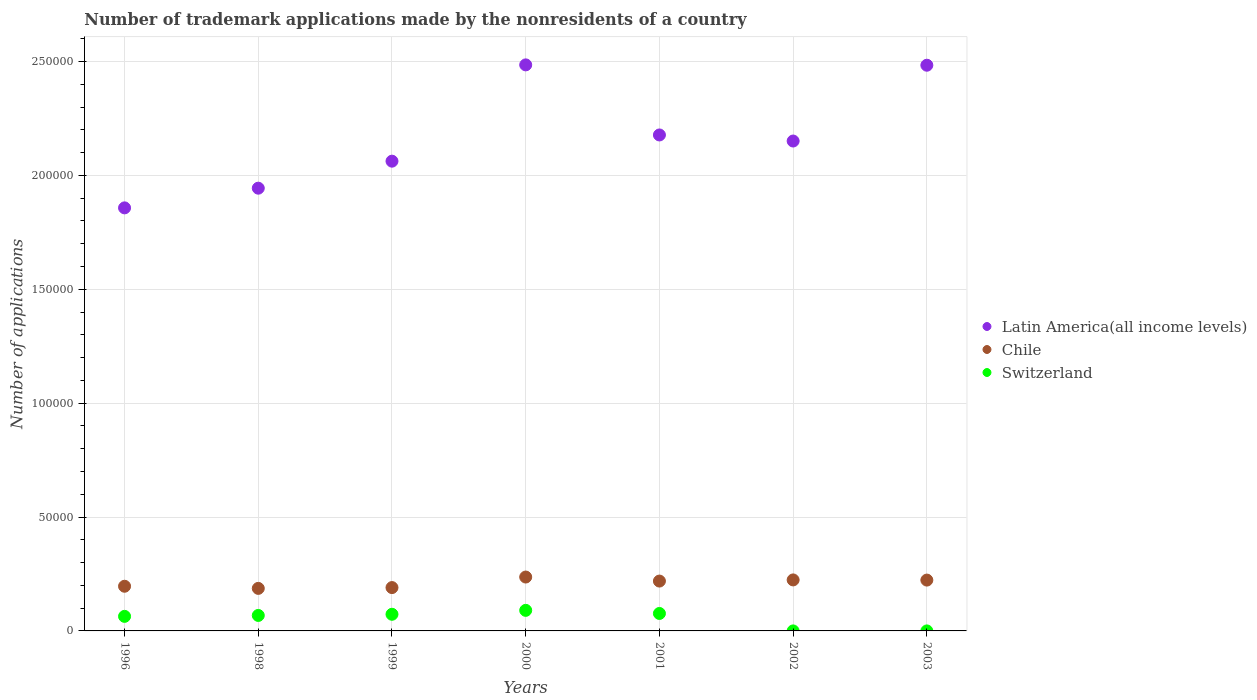Is the number of dotlines equal to the number of legend labels?
Ensure brevity in your answer.  Yes. What is the number of trademark applications made by the nonresidents in Chile in 2001?
Ensure brevity in your answer.  2.19e+04. Across all years, what is the maximum number of trademark applications made by the nonresidents in Latin America(all income levels)?
Your answer should be very brief. 2.49e+05. Across all years, what is the minimum number of trademark applications made by the nonresidents in Chile?
Give a very brief answer. 1.87e+04. In which year was the number of trademark applications made by the nonresidents in Latin America(all income levels) minimum?
Provide a succinct answer. 1996. What is the total number of trademark applications made by the nonresidents in Switzerland in the graph?
Give a very brief answer. 3.72e+04. What is the difference between the number of trademark applications made by the nonresidents in Switzerland in 1996 and that in 2000?
Make the answer very short. -2640. What is the difference between the number of trademark applications made by the nonresidents in Switzerland in 1998 and the number of trademark applications made by the nonresidents in Chile in 2001?
Your response must be concise. -1.51e+04. What is the average number of trademark applications made by the nonresidents in Chile per year?
Provide a succinct answer. 2.11e+04. In the year 2002, what is the difference between the number of trademark applications made by the nonresidents in Chile and number of trademark applications made by the nonresidents in Latin America(all income levels)?
Provide a short and direct response. -1.93e+05. In how many years, is the number of trademark applications made by the nonresidents in Latin America(all income levels) greater than 150000?
Offer a terse response. 7. What is the ratio of the number of trademark applications made by the nonresidents in Chile in 2000 to that in 2003?
Offer a terse response. 1.06. What is the difference between the highest and the second highest number of trademark applications made by the nonresidents in Switzerland?
Ensure brevity in your answer.  1365. What is the difference between the highest and the lowest number of trademark applications made by the nonresidents in Latin America(all income levels)?
Your answer should be very brief. 6.28e+04. Is it the case that in every year, the sum of the number of trademark applications made by the nonresidents in Switzerland and number of trademark applications made by the nonresidents in Latin America(all income levels)  is greater than the number of trademark applications made by the nonresidents in Chile?
Give a very brief answer. Yes. Is the number of trademark applications made by the nonresidents in Switzerland strictly less than the number of trademark applications made by the nonresidents in Latin America(all income levels) over the years?
Your response must be concise. Yes. How many dotlines are there?
Keep it short and to the point. 3. How many years are there in the graph?
Ensure brevity in your answer.  7. What is the difference between two consecutive major ticks on the Y-axis?
Your answer should be very brief. 5.00e+04. Are the values on the major ticks of Y-axis written in scientific E-notation?
Your answer should be compact. No. Does the graph contain grids?
Your answer should be compact. Yes. Where does the legend appear in the graph?
Make the answer very short. Center right. How many legend labels are there?
Provide a succinct answer. 3. How are the legend labels stacked?
Your answer should be very brief. Vertical. What is the title of the graph?
Offer a very short reply. Number of trademark applications made by the nonresidents of a country. Does "Georgia" appear as one of the legend labels in the graph?
Give a very brief answer. No. What is the label or title of the X-axis?
Ensure brevity in your answer.  Years. What is the label or title of the Y-axis?
Make the answer very short. Number of applications. What is the Number of applications in Latin America(all income levels) in 1996?
Give a very brief answer. 1.86e+05. What is the Number of applications of Chile in 1996?
Ensure brevity in your answer.  1.96e+04. What is the Number of applications in Switzerland in 1996?
Keep it short and to the point. 6390. What is the Number of applications in Latin America(all income levels) in 1998?
Ensure brevity in your answer.  1.94e+05. What is the Number of applications in Chile in 1998?
Your answer should be compact. 1.87e+04. What is the Number of applications in Switzerland in 1998?
Your response must be concise. 6796. What is the Number of applications in Latin America(all income levels) in 1999?
Offer a terse response. 2.06e+05. What is the Number of applications of Chile in 1999?
Offer a terse response. 1.90e+04. What is the Number of applications of Switzerland in 1999?
Ensure brevity in your answer.  7307. What is the Number of applications in Latin America(all income levels) in 2000?
Ensure brevity in your answer.  2.49e+05. What is the Number of applications in Chile in 2000?
Ensure brevity in your answer.  2.37e+04. What is the Number of applications in Switzerland in 2000?
Your answer should be very brief. 9030. What is the Number of applications in Latin America(all income levels) in 2001?
Offer a very short reply. 2.18e+05. What is the Number of applications in Chile in 2001?
Provide a succinct answer. 2.19e+04. What is the Number of applications in Switzerland in 2001?
Offer a terse response. 7665. What is the Number of applications in Latin America(all income levels) in 2002?
Provide a short and direct response. 2.15e+05. What is the Number of applications in Chile in 2002?
Your answer should be compact. 2.24e+04. What is the Number of applications in Latin America(all income levels) in 2003?
Provide a short and direct response. 2.48e+05. What is the Number of applications in Chile in 2003?
Ensure brevity in your answer.  2.23e+04. What is the Number of applications in Switzerland in 2003?
Keep it short and to the point. 1. Across all years, what is the maximum Number of applications of Latin America(all income levels)?
Give a very brief answer. 2.49e+05. Across all years, what is the maximum Number of applications in Chile?
Give a very brief answer. 2.37e+04. Across all years, what is the maximum Number of applications in Switzerland?
Provide a succinct answer. 9030. Across all years, what is the minimum Number of applications of Latin America(all income levels)?
Provide a short and direct response. 1.86e+05. Across all years, what is the minimum Number of applications in Chile?
Ensure brevity in your answer.  1.87e+04. Across all years, what is the minimum Number of applications in Switzerland?
Ensure brevity in your answer.  1. What is the total Number of applications of Latin America(all income levels) in the graph?
Provide a succinct answer. 1.52e+06. What is the total Number of applications of Chile in the graph?
Offer a very short reply. 1.48e+05. What is the total Number of applications in Switzerland in the graph?
Keep it short and to the point. 3.72e+04. What is the difference between the Number of applications of Latin America(all income levels) in 1996 and that in 1998?
Make the answer very short. -8641. What is the difference between the Number of applications in Chile in 1996 and that in 1998?
Offer a terse response. 937. What is the difference between the Number of applications of Switzerland in 1996 and that in 1998?
Make the answer very short. -406. What is the difference between the Number of applications in Latin America(all income levels) in 1996 and that in 1999?
Offer a terse response. -2.05e+04. What is the difference between the Number of applications in Chile in 1996 and that in 1999?
Provide a succinct answer. 585. What is the difference between the Number of applications of Switzerland in 1996 and that in 1999?
Your response must be concise. -917. What is the difference between the Number of applications of Latin America(all income levels) in 1996 and that in 2000?
Your response must be concise. -6.28e+04. What is the difference between the Number of applications of Chile in 1996 and that in 2000?
Provide a short and direct response. -4044. What is the difference between the Number of applications in Switzerland in 1996 and that in 2000?
Provide a short and direct response. -2640. What is the difference between the Number of applications of Latin America(all income levels) in 1996 and that in 2001?
Keep it short and to the point. -3.20e+04. What is the difference between the Number of applications of Chile in 1996 and that in 2001?
Provide a short and direct response. -2274. What is the difference between the Number of applications in Switzerland in 1996 and that in 2001?
Keep it short and to the point. -1275. What is the difference between the Number of applications of Latin America(all income levels) in 1996 and that in 2002?
Give a very brief answer. -2.93e+04. What is the difference between the Number of applications of Chile in 1996 and that in 2002?
Offer a terse response. -2779. What is the difference between the Number of applications of Switzerland in 1996 and that in 2002?
Keep it short and to the point. 6389. What is the difference between the Number of applications in Latin America(all income levels) in 1996 and that in 2003?
Make the answer very short. -6.26e+04. What is the difference between the Number of applications of Chile in 1996 and that in 2003?
Your response must be concise. -2705. What is the difference between the Number of applications in Switzerland in 1996 and that in 2003?
Your answer should be very brief. 6389. What is the difference between the Number of applications of Latin America(all income levels) in 1998 and that in 1999?
Give a very brief answer. -1.19e+04. What is the difference between the Number of applications of Chile in 1998 and that in 1999?
Offer a very short reply. -352. What is the difference between the Number of applications of Switzerland in 1998 and that in 1999?
Make the answer very short. -511. What is the difference between the Number of applications of Latin America(all income levels) in 1998 and that in 2000?
Offer a terse response. -5.41e+04. What is the difference between the Number of applications of Chile in 1998 and that in 2000?
Ensure brevity in your answer.  -4981. What is the difference between the Number of applications in Switzerland in 1998 and that in 2000?
Make the answer very short. -2234. What is the difference between the Number of applications in Latin America(all income levels) in 1998 and that in 2001?
Offer a terse response. -2.34e+04. What is the difference between the Number of applications in Chile in 1998 and that in 2001?
Give a very brief answer. -3211. What is the difference between the Number of applications of Switzerland in 1998 and that in 2001?
Make the answer very short. -869. What is the difference between the Number of applications in Latin America(all income levels) in 1998 and that in 2002?
Keep it short and to the point. -2.07e+04. What is the difference between the Number of applications in Chile in 1998 and that in 2002?
Keep it short and to the point. -3716. What is the difference between the Number of applications in Switzerland in 1998 and that in 2002?
Keep it short and to the point. 6795. What is the difference between the Number of applications of Latin America(all income levels) in 1998 and that in 2003?
Offer a very short reply. -5.40e+04. What is the difference between the Number of applications in Chile in 1998 and that in 2003?
Your answer should be very brief. -3642. What is the difference between the Number of applications of Switzerland in 1998 and that in 2003?
Give a very brief answer. 6795. What is the difference between the Number of applications of Latin America(all income levels) in 1999 and that in 2000?
Your answer should be compact. -4.23e+04. What is the difference between the Number of applications in Chile in 1999 and that in 2000?
Offer a terse response. -4629. What is the difference between the Number of applications of Switzerland in 1999 and that in 2000?
Your response must be concise. -1723. What is the difference between the Number of applications of Latin America(all income levels) in 1999 and that in 2001?
Your answer should be compact. -1.15e+04. What is the difference between the Number of applications of Chile in 1999 and that in 2001?
Ensure brevity in your answer.  -2859. What is the difference between the Number of applications of Switzerland in 1999 and that in 2001?
Offer a very short reply. -358. What is the difference between the Number of applications of Latin America(all income levels) in 1999 and that in 2002?
Ensure brevity in your answer.  -8844. What is the difference between the Number of applications of Chile in 1999 and that in 2002?
Provide a succinct answer. -3364. What is the difference between the Number of applications in Switzerland in 1999 and that in 2002?
Ensure brevity in your answer.  7306. What is the difference between the Number of applications in Latin America(all income levels) in 1999 and that in 2003?
Keep it short and to the point. -4.21e+04. What is the difference between the Number of applications in Chile in 1999 and that in 2003?
Your response must be concise. -3290. What is the difference between the Number of applications of Switzerland in 1999 and that in 2003?
Offer a very short reply. 7306. What is the difference between the Number of applications in Latin America(all income levels) in 2000 and that in 2001?
Your answer should be compact. 3.08e+04. What is the difference between the Number of applications in Chile in 2000 and that in 2001?
Your response must be concise. 1770. What is the difference between the Number of applications in Switzerland in 2000 and that in 2001?
Provide a succinct answer. 1365. What is the difference between the Number of applications of Latin America(all income levels) in 2000 and that in 2002?
Provide a succinct answer. 3.34e+04. What is the difference between the Number of applications of Chile in 2000 and that in 2002?
Your answer should be very brief. 1265. What is the difference between the Number of applications of Switzerland in 2000 and that in 2002?
Offer a terse response. 9029. What is the difference between the Number of applications in Latin America(all income levels) in 2000 and that in 2003?
Provide a short and direct response. 152. What is the difference between the Number of applications in Chile in 2000 and that in 2003?
Provide a short and direct response. 1339. What is the difference between the Number of applications in Switzerland in 2000 and that in 2003?
Give a very brief answer. 9029. What is the difference between the Number of applications of Latin America(all income levels) in 2001 and that in 2002?
Your answer should be compact. 2664. What is the difference between the Number of applications in Chile in 2001 and that in 2002?
Keep it short and to the point. -505. What is the difference between the Number of applications in Switzerland in 2001 and that in 2002?
Keep it short and to the point. 7664. What is the difference between the Number of applications of Latin America(all income levels) in 2001 and that in 2003?
Offer a terse response. -3.06e+04. What is the difference between the Number of applications of Chile in 2001 and that in 2003?
Give a very brief answer. -431. What is the difference between the Number of applications in Switzerland in 2001 and that in 2003?
Provide a succinct answer. 7664. What is the difference between the Number of applications in Latin America(all income levels) in 2002 and that in 2003?
Offer a terse response. -3.33e+04. What is the difference between the Number of applications in Switzerland in 2002 and that in 2003?
Ensure brevity in your answer.  0. What is the difference between the Number of applications in Latin America(all income levels) in 1996 and the Number of applications in Chile in 1998?
Keep it short and to the point. 1.67e+05. What is the difference between the Number of applications in Latin America(all income levels) in 1996 and the Number of applications in Switzerland in 1998?
Keep it short and to the point. 1.79e+05. What is the difference between the Number of applications of Chile in 1996 and the Number of applications of Switzerland in 1998?
Your answer should be compact. 1.28e+04. What is the difference between the Number of applications in Latin America(all income levels) in 1996 and the Number of applications in Chile in 1999?
Your response must be concise. 1.67e+05. What is the difference between the Number of applications of Latin America(all income levels) in 1996 and the Number of applications of Switzerland in 1999?
Provide a succinct answer. 1.78e+05. What is the difference between the Number of applications in Chile in 1996 and the Number of applications in Switzerland in 1999?
Your answer should be compact. 1.23e+04. What is the difference between the Number of applications in Latin America(all income levels) in 1996 and the Number of applications in Chile in 2000?
Provide a short and direct response. 1.62e+05. What is the difference between the Number of applications in Latin America(all income levels) in 1996 and the Number of applications in Switzerland in 2000?
Give a very brief answer. 1.77e+05. What is the difference between the Number of applications of Chile in 1996 and the Number of applications of Switzerland in 2000?
Give a very brief answer. 1.06e+04. What is the difference between the Number of applications of Latin America(all income levels) in 1996 and the Number of applications of Chile in 2001?
Keep it short and to the point. 1.64e+05. What is the difference between the Number of applications of Latin America(all income levels) in 1996 and the Number of applications of Switzerland in 2001?
Your response must be concise. 1.78e+05. What is the difference between the Number of applications of Chile in 1996 and the Number of applications of Switzerland in 2001?
Your answer should be compact. 1.19e+04. What is the difference between the Number of applications in Latin America(all income levels) in 1996 and the Number of applications in Chile in 2002?
Ensure brevity in your answer.  1.63e+05. What is the difference between the Number of applications in Latin America(all income levels) in 1996 and the Number of applications in Switzerland in 2002?
Your answer should be compact. 1.86e+05. What is the difference between the Number of applications of Chile in 1996 and the Number of applications of Switzerland in 2002?
Your answer should be compact. 1.96e+04. What is the difference between the Number of applications in Latin America(all income levels) in 1996 and the Number of applications in Chile in 2003?
Offer a terse response. 1.63e+05. What is the difference between the Number of applications in Latin America(all income levels) in 1996 and the Number of applications in Switzerland in 2003?
Offer a terse response. 1.86e+05. What is the difference between the Number of applications of Chile in 1996 and the Number of applications of Switzerland in 2003?
Give a very brief answer. 1.96e+04. What is the difference between the Number of applications of Latin America(all income levels) in 1998 and the Number of applications of Chile in 1999?
Offer a terse response. 1.75e+05. What is the difference between the Number of applications in Latin America(all income levels) in 1998 and the Number of applications in Switzerland in 1999?
Provide a short and direct response. 1.87e+05. What is the difference between the Number of applications of Chile in 1998 and the Number of applications of Switzerland in 1999?
Ensure brevity in your answer.  1.14e+04. What is the difference between the Number of applications of Latin America(all income levels) in 1998 and the Number of applications of Chile in 2000?
Your answer should be compact. 1.71e+05. What is the difference between the Number of applications of Latin America(all income levels) in 1998 and the Number of applications of Switzerland in 2000?
Provide a succinct answer. 1.85e+05. What is the difference between the Number of applications of Chile in 1998 and the Number of applications of Switzerland in 2000?
Your response must be concise. 9646. What is the difference between the Number of applications of Latin America(all income levels) in 1998 and the Number of applications of Chile in 2001?
Offer a very short reply. 1.72e+05. What is the difference between the Number of applications of Latin America(all income levels) in 1998 and the Number of applications of Switzerland in 2001?
Offer a very short reply. 1.87e+05. What is the difference between the Number of applications in Chile in 1998 and the Number of applications in Switzerland in 2001?
Your answer should be compact. 1.10e+04. What is the difference between the Number of applications in Latin America(all income levels) in 1998 and the Number of applications in Chile in 2002?
Offer a terse response. 1.72e+05. What is the difference between the Number of applications in Latin America(all income levels) in 1998 and the Number of applications in Switzerland in 2002?
Offer a very short reply. 1.94e+05. What is the difference between the Number of applications in Chile in 1998 and the Number of applications in Switzerland in 2002?
Ensure brevity in your answer.  1.87e+04. What is the difference between the Number of applications in Latin America(all income levels) in 1998 and the Number of applications in Chile in 2003?
Your answer should be very brief. 1.72e+05. What is the difference between the Number of applications in Latin America(all income levels) in 1998 and the Number of applications in Switzerland in 2003?
Make the answer very short. 1.94e+05. What is the difference between the Number of applications in Chile in 1998 and the Number of applications in Switzerland in 2003?
Offer a terse response. 1.87e+04. What is the difference between the Number of applications in Latin America(all income levels) in 1999 and the Number of applications in Chile in 2000?
Make the answer very short. 1.83e+05. What is the difference between the Number of applications in Latin America(all income levels) in 1999 and the Number of applications in Switzerland in 2000?
Your answer should be compact. 1.97e+05. What is the difference between the Number of applications of Chile in 1999 and the Number of applications of Switzerland in 2000?
Keep it short and to the point. 9998. What is the difference between the Number of applications of Latin America(all income levels) in 1999 and the Number of applications of Chile in 2001?
Provide a succinct answer. 1.84e+05. What is the difference between the Number of applications in Latin America(all income levels) in 1999 and the Number of applications in Switzerland in 2001?
Provide a short and direct response. 1.99e+05. What is the difference between the Number of applications in Chile in 1999 and the Number of applications in Switzerland in 2001?
Make the answer very short. 1.14e+04. What is the difference between the Number of applications of Latin America(all income levels) in 1999 and the Number of applications of Chile in 2002?
Your response must be concise. 1.84e+05. What is the difference between the Number of applications of Latin America(all income levels) in 1999 and the Number of applications of Switzerland in 2002?
Make the answer very short. 2.06e+05. What is the difference between the Number of applications in Chile in 1999 and the Number of applications in Switzerland in 2002?
Your answer should be very brief. 1.90e+04. What is the difference between the Number of applications of Latin America(all income levels) in 1999 and the Number of applications of Chile in 2003?
Your response must be concise. 1.84e+05. What is the difference between the Number of applications of Latin America(all income levels) in 1999 and the Number of applications of Switzerland in 2003?
Keep it short and to the point. 2.06e+05. What is the difference between the Number of applications of Chile in 1999 and the Number of applications of Switzerland in 2003?
Provide a succinct answer. 1.90e+04. What is the difference between the Number of applications of Latin America(all income levels) in 2000 and the Number of applications of Chile in 2001?
Ensure brevity in your answer.  2.27e+05. What is the difference between the Number of applications in Latin America(all income levels) in 2000 and the Number of applications in Switzerland in 2001?
Keep it short and to the point. 2.41e+05. What is the difference between the Number of applications of Chile in 2000 and the Number of applications of Switzerland in 2001?
Provide a short and direct response. 1.60e+04. What is the difference between the Number of applications of Latin America(all income levels) in 2000 and the Number of applications of Chile in 2002?
Provide a short and direct response. 2.26e+05. What is the difference between the Number of applications of Latin America(all income levels) in 2000 and the Number of applications of Switzerland in 2002?
Give a very brief answer. 2.49e+05. What is the difference between the Number of applications in Chile in 2000 and the Number of applications in Switzerland in 2002?
Your response must be concise. 2.37e+04. What is the difference between the Number of applications of Latin America(all income levels) in 2000 and the Number of applications of Chile in 2003?
Provide a succinct answer. 2.26e+05. What is the difference between the Number of applications of Latin America(all income levels) in 2000 and the Number of applications of Switzerland in 2003?
Your answer should be compact. 2.49e+05. What is the difference between the Number of applications of Chile in 2000 and the Number of applications of Switzerland in 2003?
Your answer should be compact. 2.37e+04. What is the difference between the Number of applications of Latin America(all income levels) in 2001 and the Number of applications of Chile in 2002?
Keep it short and to the point. 1.95e+05. What is the difference between the Number of applications of Latin America(all income levels) in 2001 and the Number of applications of Switzerland in 2002?
Keep it short and to the point. 2.18e+05. What is the difference between the Number of applications of Chile in 2001 and the Number of applications of Switzerland in 2002?
Your response must be concise. 2.19e+04. What is the difference between the Number of applications of Latin America(all income levels) in 2001 and the Number of applications of Chile in 2003?
Your answer should be compact. 1.95e+05. What is the difference between the Number of applications of Latin America(all income levels) in 2001 and the Number of applications of Switzerland in 2003?
Offer a very short reply. 2.18e+05. What is the difference between the Number of applications in Chile in 2001 and the Number of applications in Switzerland in 2003?
Offer a very short reply. 2.19e+04. What is the difference between the Number of applications in Latin America(all income levels) in 2002 and the Number of applications in Chile in 2003?
Provide a short and direct response. 1.93e+05. What is the difference between the Number of applications of Latin America(all income levels) in 2002 and the Number of applications of Switzerland in 2003?
Ensure brevity in your answer.  2.15e+05. What is the difference between the Number of applications in Chile in 2002 and the Number of applications in Switzerland in 2003?
Offer a very short reply. 2.24e+04. What is the average Number of applications of Latin America(all income levels) per year?
Keep it short and to the point. 2.17e+05. What is the average Number of applications of Chile per year?
Provide a short and direct response. 2.11e+04. What is the average Number of applications of Switzerland per year?
Provide a succinct answer. 5312.86. In the year 1996, what is the difference between the Number of applications in Latin America(all income levels) and Number of applications in Chile?
Offer a terse response. 1.66e+05. In the year 1996, what is the difference between the Number of applications in Latin America(all income levels) and Number of applications in Switzerland?
Ensure brevity in your answer.  1.79e+05. In the year 1996, what is the difference between the Number of applications of Chile and Number of applications of Switzerland?
Your response must be concise. 1.32e+04. In the year 1998, what is the difference between the Number of applications in Latin America(all income levels) and Number of applications in Chile?
Offer a terse response. 1.76e+05. In the year 1998, what is the difference between the Number of applications in Latin America(all income levels) and Number of applications in Switzerland?
Your response must be concise. 1.88e+05. In the year 1998, what is the difference between the Number of applications in Chile and Number of applications in Switzerland?
Give a very brief answer. 1.19e+04. In the year 1999, what is the difference between the Number of applications in Latin America(all income levels) and Number of applications in Chile?
Ensure brevity in your answer.  1.87e+05. In the year 1999, what is the difference between the Number of applications of Latin America(all income levels) and Number of applications of Switzerland?
Ensure brevity in your answer.  1.99e+05. In the year 1999, what is the difference between the Number of applications in Chile and Number of applications in Switzerland?
Provide a succinct answer. 1.17e+04. In the year 2000, what is the difference between the Number of applications in Latin America(all income levels) and Number of applications in Chile?
Ensure brevity in your answer.  2.25e+05. In the year 2000, what is the difference between the Number of applications in Latin America(all income levels) and Number of applications in Switzerland?
Your response must be concise. 2.39e+05. In the year 2000, what is the difference between the Number of applications of Chile and Number of applications of Switzerland?
Ensure brevity in your answer.  1.46e+04. In the year 2001, what is the difference between the Number of applications in Latin America(all income levels) and Number of applications in Chile?
Make the answer very short. 1.96e+05. In the year 2001, what is the difference between the Number of applications in Latin America(all income levels) and Number of applications in Switzerland?
Make the answer very short. 2.10e+05. In the year 2001, what is the difference between the Number of applications of Chile and Number of applications of Switzerland?
Provide a succinct answer. 1.42e+04. In the year 2002, what is the difference between the Number of applications in Latin America(all income levels) and Number of applications in Chile?
Your answer should be very brief. 1.93e+05. In the year 2002, what is the difference between the Number of applications in Latin America(all income levels) and Number of applications in Switzerland?
Give a very brief answer. 2.15e+05. In the year 2002, what is the difference between the Number of applications of Chile and Number of applications of Switzerland?
Offer a very short reply. 2.24e+04. In the year 2003, what is the difference between the Number of applications of Latin America(all income levels) and Number of applications of Chile?
Provide a succinct answer. 2.26e+05. In the year 2003, what is the difference between the Number of applications of Latin America(all income levels) and Number of applications of Switzerland?
Offer a very short reply. 2.48e+05. In the year 2003, what is the difference between the Number of applications in Chile and Number of applications in Switzerland?
Keep it short and to the point. 2.23e+04. What is the ratio of the Number of applications in Latin America(all income levels) in 1996 to that in 1998?
Your answer should be very brief. 0.96. What is the ratio of the Number of applications in Chile in 1996 to that in 1998?
Provide a short and direct response. 1.05. What is the ratio of the Number of applications in Switzerland in 1996 to that in 1998?
Your answer should be compact. 0.94. What is the ratio of the Number of applications in Latin America(all income levels) in 1996 to that in 1999?
Ensure brevity in your answer.  0.9. What is the ratio of the Number of applications of Chile in 1996 to that in 1999?
Offer a terse response. 1.03. What is the ratio of the Number of applications in Switzerland in 1996 to that in 1999?
Keep it short and to the point. 0.87. What is the ratio of the Number of applications in Latin America(all income levels) in 1996 to that in 2000?
Offer a very short reply. 0.75. What is the ratio of the Number of applications in Chile in 1996 to that in 2000?
Provide a succinct answer. 0.83. What is the ratio of the Number of applications of Switzerland in 1996 to that in 2000?
Ensure brevity in your answer.  0.71. What is the ratio of the Number of applications in Latin America(all income levels) in 1996 to that in 2001?
Make the answer very short. 0.85. What is the ratio of the Number of applications of Chile in 1996 to that in 2001?
Ensure brevity in your answer.  0.9. What is the ratio of the Number of applications in Switzerland in 1996 to that in 2001?
Keep it short and to the point. 0.83. What is the ratio of the Number of applications in Latin America(all income levels) in 1996 to that in 2002?
Provide a short and direct response. 0.86. What is the ratio of the Number of applications of Chile in 1996 to that in 2002?
Your response must be concise. 0.88. What is the ratio of the Number of applications in Switzerland in 1996 to that in 2002?
Offer a terse response. 6390. What is the ratio of the Number of applications of Latin America(all income levels) in 1996 to that in 2003?
Keep it short and to the point. 0.75. What is the ratio of the Number of applications in Chile in 1996 to that in 2003?
Keep it short and to the point. 0.88. What is the ratio of the Number of applications of Switzerland in 1996 to that in 2003?
Offer a terse response. 6390. What is the ratio of the Number of applications in Latin America(all income levels) in 1998 to that in 1999?
Make the answer very short. 0.94. What is the ratio of the Number of applications of Chile in 1998 to that in 1999?
Offer a very short reply. 0.98. What is the ratio of the Number of applications of Switzerland in 1998 to that in 1999?
Ensure brevity in your answer.  0.93. What is the ratio of the Number of applications of Latin America(all income levels) in 1998 to that in 2000?
Give a very brief answer. 0.78. What is the ratio of the Number of applications of Chile in 1998 to that in 2000?
Offer a very short reply. 0.79. What is the ratio of the Number of applications of Switzerland in 1998 to that in 2000?
Offer a terse response. 0.75. What is the ratio of the Number of applications in Latin America(all income levels) in 1998 to that in 2001?
Ensure brevity in your answer.  0.89. What is the ratio of the Number of applications in Chile in 1998 to that in 2001?
Give a very brief answer. 0.85. What is the ratio of the Number of applications in Switzerland in 1998 to that in 2001?
Your response must be concise. 0.89. What is the ratio of the Number of applications in Latin America(all income levels) in 1998 to that in 2002?
Provide a short and direct response. 0.9. What is the ratio of the Number of applications of Chile in 1998 to that in 2002?
Make the answer very short. 0.83. What is the ratio of the Number of applications in Switzerland in 1998 to that in 2002?
Ensure brevity in your answer.  6796. What is the ratio of the Number of applications of Latin America(all income levels) in 1998 to that in 2003?
Offer a terse response. 0.78. What is the ratio of the Number of applications of Chile in 1998 to that in 2003?
Your answer should be compact. 0.84. What is the ratio of the Number of applications of Switzerland in 1998 to that in 2003?
Your answer should be compact. 6796. What is the ratio of the Number of applications of Latin America(all income levels) in 1999 to that in 2000?
Provide a short and direct response. 0.83. What is the ratio of the Number of applications in Chile in 1999 to that in 2000?
Keep it short and to the point. 0.8. What is the ratio of the Number of applications in Switzerland in 1999 to that in 2000?
Your response must be concise. 0.81. What is the ratio of the Number of applications in Latin America(all income levels) in 1999 to that in 2001?
Offer a very short reply. 0.95. What is the ratio of the Number of applications of Chile in 1999 to that in 2001?
Provide a short and direct response. 0.87. What is the ratio of the Number of applications of Switzerland in 1999 to that in 2001?
Keep it short and to the point. 0.95. What is the ratio of the Number of applications in Latin America(all income levels) in 1999 to that in 2002?
Provide a succinct answer. 0.96. What is the ratio of the Number of applications in Chile in 1999 to that in 2002?
Offer a very short reply. 0.85. What is the ratio of the Number of applications in Switzerland in 1999 to that in 2002?
Ensure brevity in your answer.  7307. What is the ratio of the Number of applications in Latin America(all income levels) in 1999 to that in 2003?
Provide a short and direct response. 0.83. What is the ratio of the Number of applications in Chile in 1999 to that in 2003?
Your answer should be very brief. 0.85. What is the ratio of the Number of applications of Switzerland in 1999 to that in 2003?
Provide a short and direct response. 7307. What is the ratio of the Number of applications of Latin America(all income levels) in 2000 to that in 2001?
Your answer should be very brief. 1.14. What is the ratio of the Number of applications in Chile in 2000 to that in 2001?
Offer a very short reply. 1.08. What is the ratio of the Number of applications of Switzerland in 2000 to that in 2001?
Your answer should be compact. 1.18. What is the ratio of the Number of applications of Latin America(all income levels) in 2000 to that in 2002?
Give a very brief answer. 1.16. What is the ratio of the Number of applications in Chile in 2000 to that in 2002?
Offer a very short reply. 1.06. What is the ratio of the Number of applications in Switzerland in 2000 to that in 2002?
Keep it short and to the point. 9030. What is the ratio of the Number of applications of Latin America(all income levels) in 2000 to that in 2003?
Offer a very short reply. 1. What is the ratio of the Number of applications of Chile in 2000 to that in 2003?
Ensure brevity in your answer.  1.06. What is the ratio of the Number of applications of Switzerland in 2000 to that in 2003?
Make the answer very short. 9030. What is the ratio of the Number of applications of Latin America(all income levels) in 2001 to that in 2002?
Make the answer very short. 1.01. What is the ratio of the Number of applications of Chile in 2001 to that in 2002?
Offer a terse response. 0.98. What is the ratio of the Number of applications of Switzerland in 2001 to that in 2002?
Your response must be concise. 7665. What is the ratio of the Number of applications of Latin America(all income levels) in 2001 to that in 2003?
Ensure brevity in your answer.  0.88. What is the ratio of the Number of applications in Chile in 2001 to that in 2003?
Offer a very short reply. 0.98. What is the ratio of the Number of applications in Switzerland in 2001 to that in 2003?
Provide a succinct answer. 7665. What is the ratio of the Number of applications in Latin America(all income levels) in 2002 to that in 2003?
Your answer should be very brief. 0.87. What is the ratio of the Number of applications in Chile in 2002 to that in 2003?
Offer a very short reply. 1. What is the ratio of the Number of applications in Switzerland in 2002 to that in 2003?
Your response must be concise. 1. What is the difference between the highest and the second highest Number of applications in Latin America(all income levels)?
Your response must be concise. 152. What is the difference between the highest and the second highest Number of applications of Chile?
Your answer should be compact. 1265. What is the difference between the highest and the second highest Number of applications in Switzerland?
Offer a terse response. 1365. What is the difference between the highest and the lowest Number of applications in Latin America(all income levels)?
Provide a short and direct response. 6.28e+04. What is the difference between the highest and the lowest Number of applications in Chile?
Make the answer very short. 4981. What is the difference between the highest and the lowest Number of applications of Switzerland?
Offer a very short reply. 9029. 